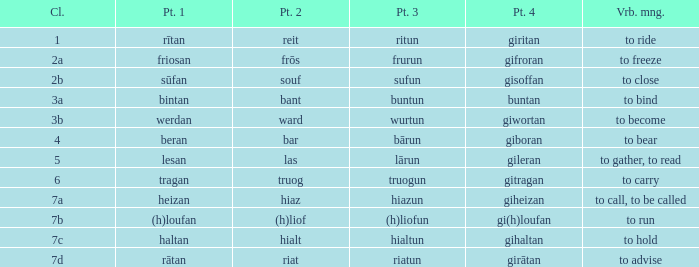What is the part 4 when part 1 is "lesan"? Gileran. 